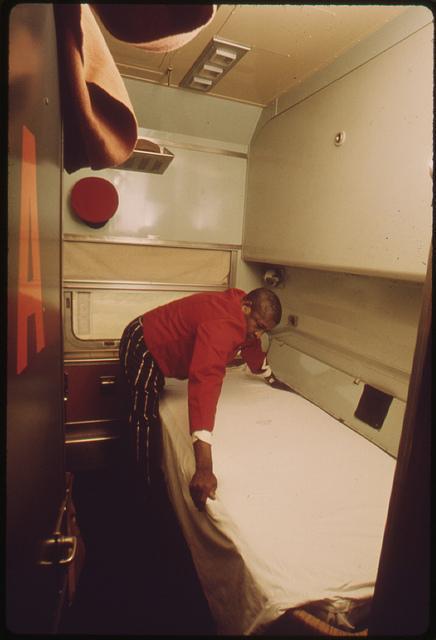How many people are there?
Give a very brief answer. 1. 